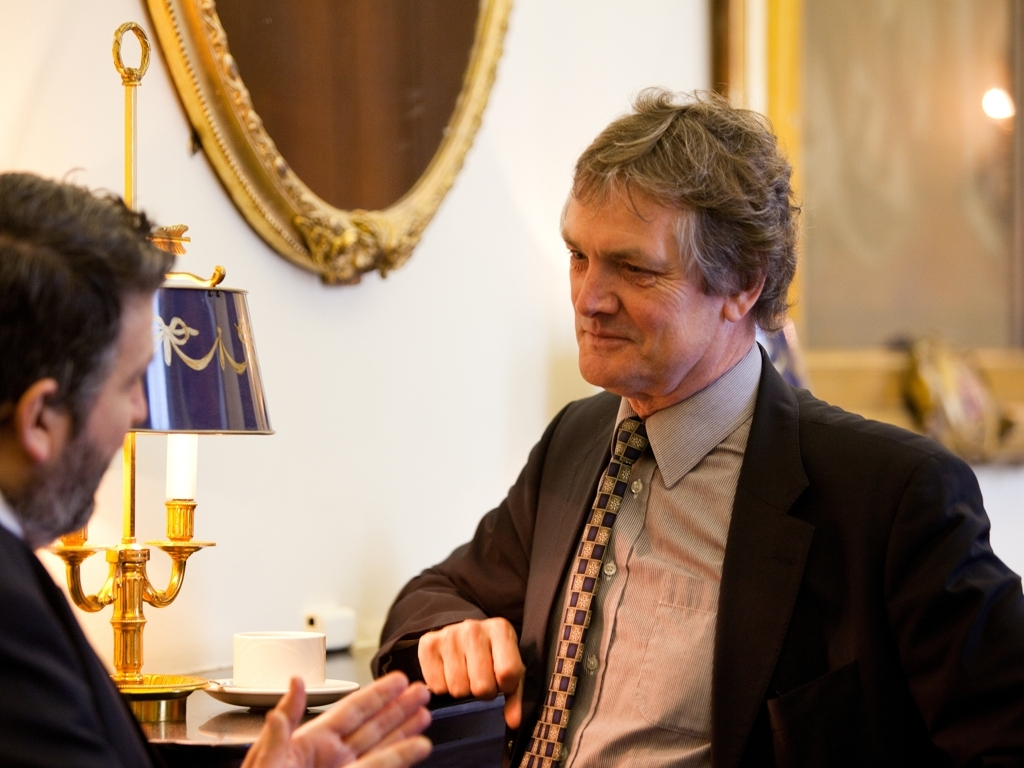Can you infer any details about the individuals in the image based on their appearance and environment? The individual in the foreground appears to be well-dressed in a business suit with a distinctive tie, which indicates a sense of professionalism and possibly a high-ranking position in a corporate or political setting. The traditional and lavish environment suggests that they are in a place of significance, possibly a government building, historic site, or a formal institution, adding to the gravitas of the situation. 